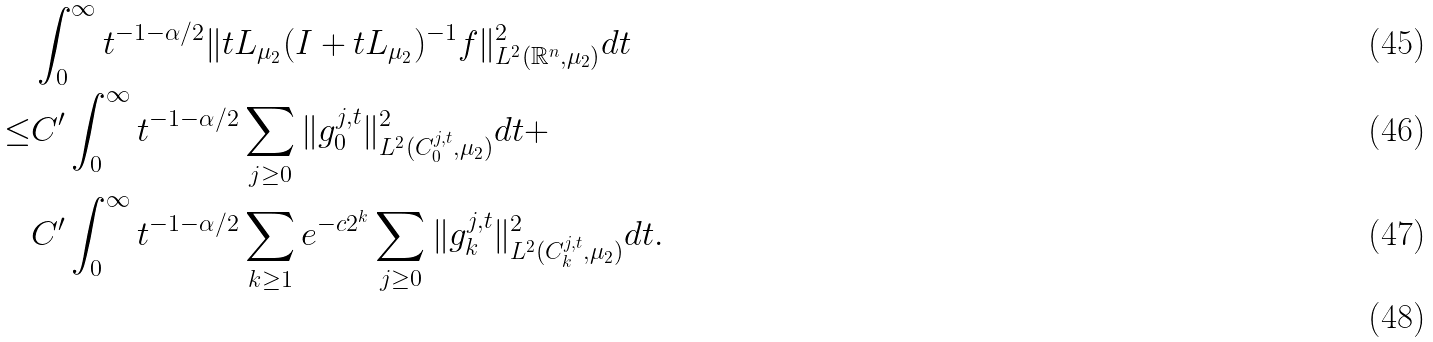<formula> <loc_0><loc_0><loc_500><loc_500>& \int _ { 0 } ^ { \infty } t ^ { - 1 - \alpha / 2 } \| t L _ { \mu _ { 2 } } ( I + t L _ { \mu _ { 2 } } ) ^ { - 1 } f \| ^ { 2 } _ { L ^ { 2 } ( \mathbb { R } ^ { n } , \mu _ { 2 } ) } d t \\ \leq & C ^ { \prime } \int _ { 0 } ^ { \infty } t ^ { - 1 - \alpha / 2 } \sum _ { j \geq 0 } \| g _ { 0 } ^ { j , t } \| ^ { 2 } _ { L ^ { 2 } ( C ^ { j , t } _ { 0 } , \mu _ { 2 } ) } d t + \\ & C ^ { \prime } \int _ { 0 } ^ { \infty } t ^ { - 1 - \alpha / 2 } \sum _ { k \geq 1 } e ^ { - c 2 ^ { k } } \sum _ { j \geq 0 } \| g _ { k } ^ { j , t } \| ^ { 2 } _ { L ^ { 2 } ( C ^ { j , t } _ { k } , \mu _ { 2 } ) } d t . \\</formula> 